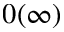Convert formula to latex. <formula><loc_0><loc_0><loc_500><loc_500>0 ( \infty )</formula> 